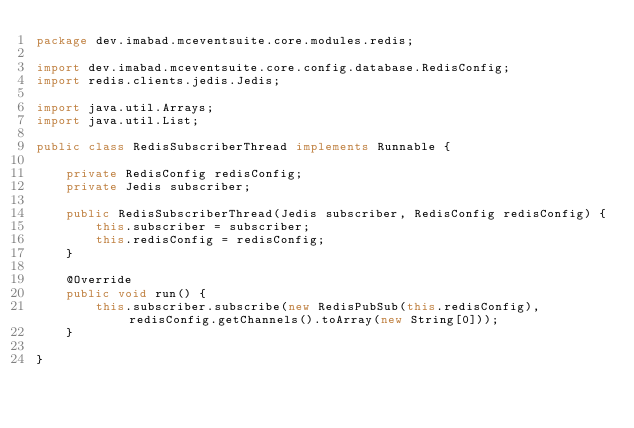Convert code to text. <code><loc_0><loc_0><loc_500><loc_500><_Java_>package dev.imabad.mceventsuite.core.modules.redis;

import dev.imabad.mceventsuite.core.config.database.RedisConfig;
import redis.clients.jedis.Jedis;

import java.util.Arrays;
import java.util.List;

public class RedisSubscriberThread implements Runnable {

    private RedisConfig redisConfig;
    private Jedis subscriber;

    public RedisSubscriberThread(Jedis subscriber, RedisConfig redisConfig) {
        this.subscriber = subscriber;
        this.redisConfig = redisConfig;
    }

    @Override
    public void run() {
        this.subscriber.subscribe(new RedisPubSub(this.redisConfig), redisConfig.getChannels().toArray(new String[0]));
    }

}
</code> 